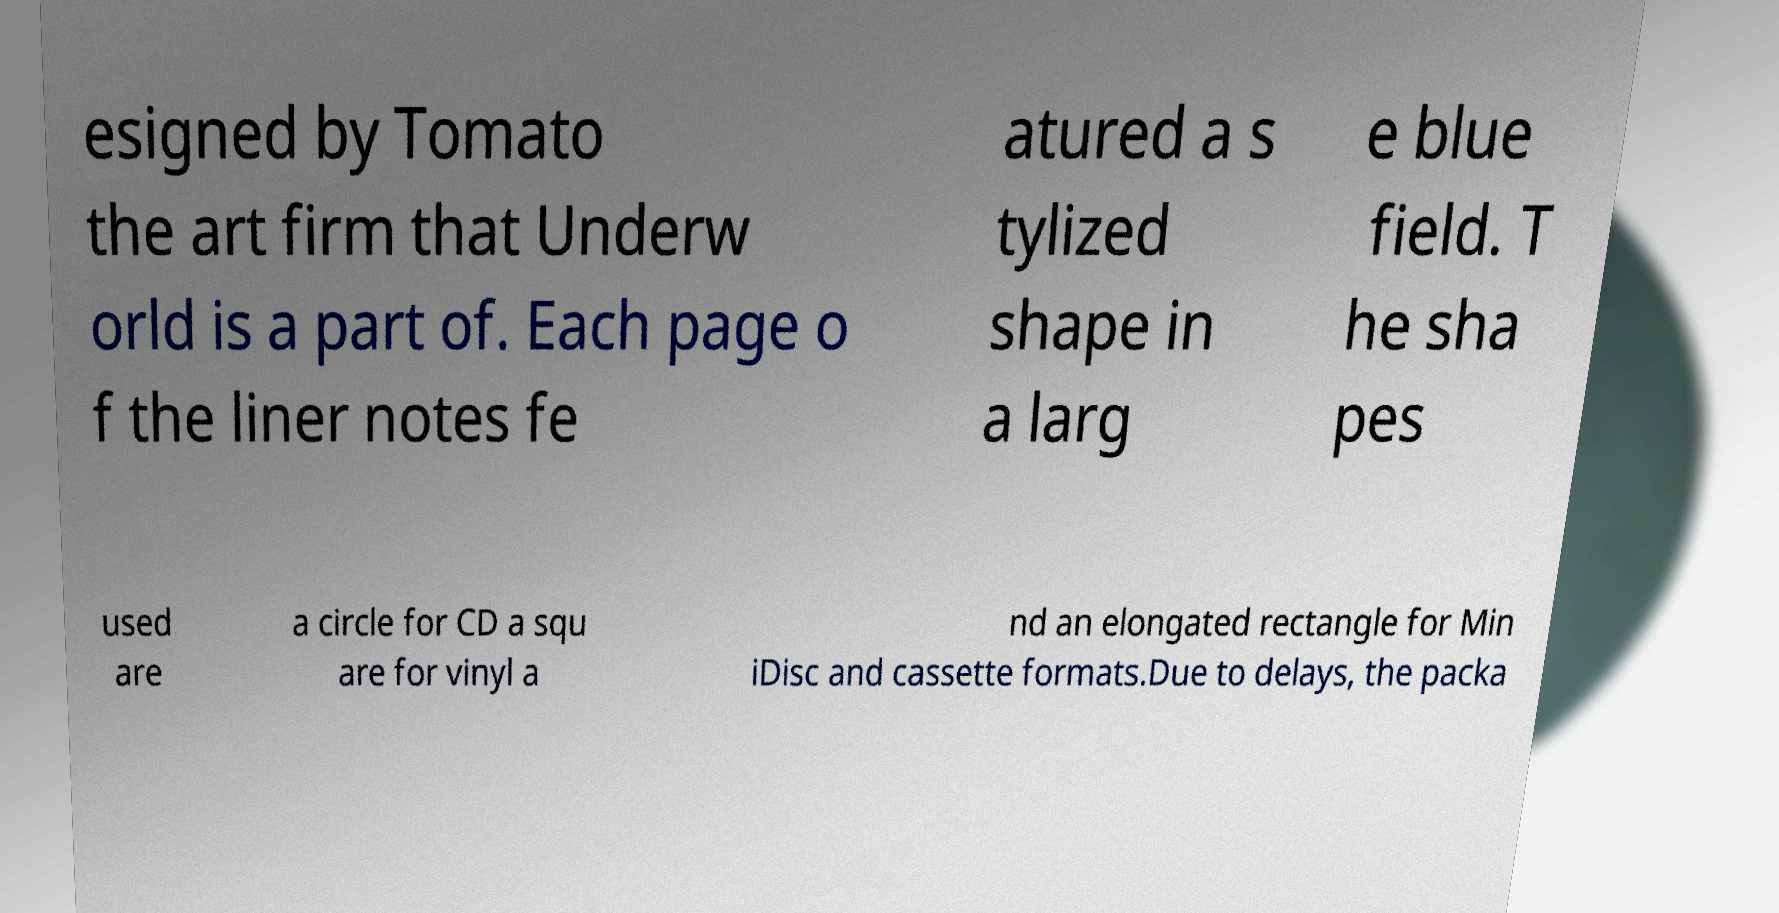There's text embedded in this image that I need extracted. Can you transcribe it verbatim? esigned by Tomato the art firm that Underw orld is a part of. Each page o f the liner notes fe atured a s tylized shape in a larg e blue field. T he sha pes used are a circle for CD a squ are for vinyl a nd an elongated rectangle for Min iDisc and cassette formats.Due to delays, the packa 